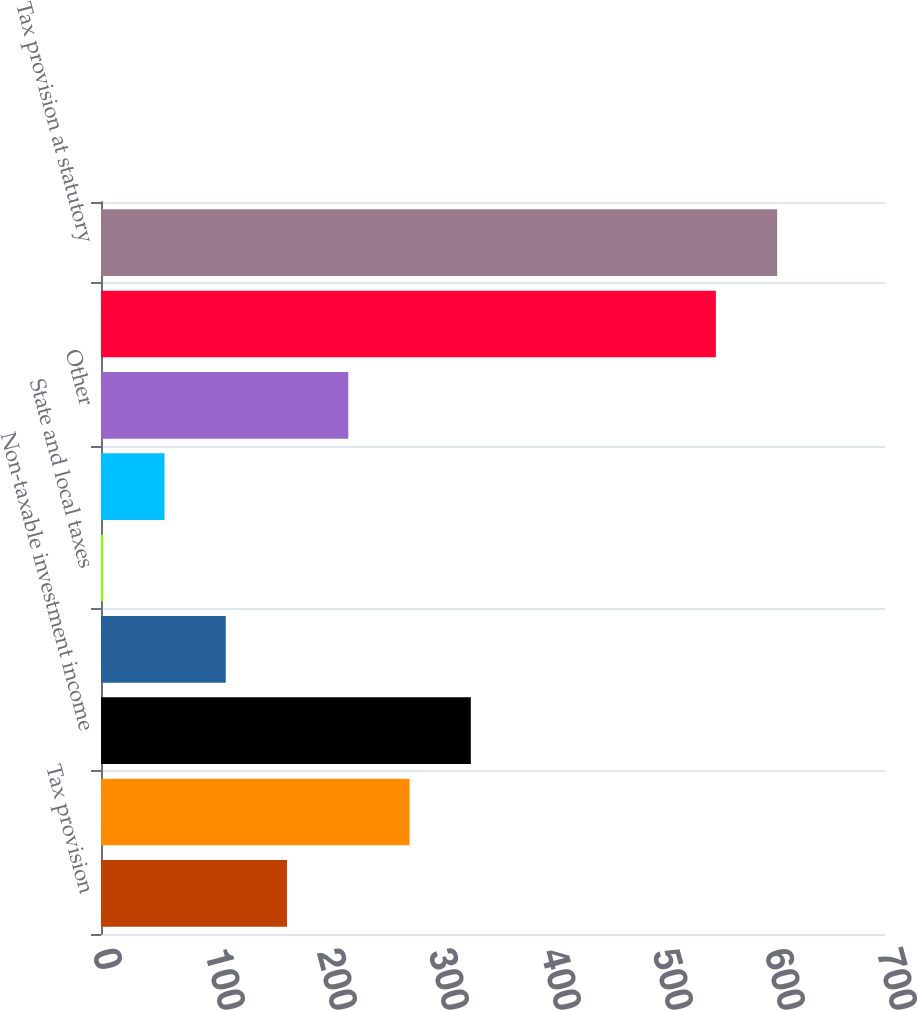<chart> <loc_0><loc_0><loc_500><loc_500><bar_chart><fcel>Tax provision<fcel>Low income housing and other<fcel>Non-taxable investment income<fcel>Foreign taxes at other than US<fcel>State and local taxes<fcel>Non-deductible expenses<fcel>Other<fcel>Tax provision excluding these<fcel>Tax provision at statutory<nl><fcel>166.1<fcel>275.5<fcel>330.2<fcel>111.4<fcel>2<fcel>56.7<fcel>220.8<fcel>549<fcel>603.7<nl></chart> 